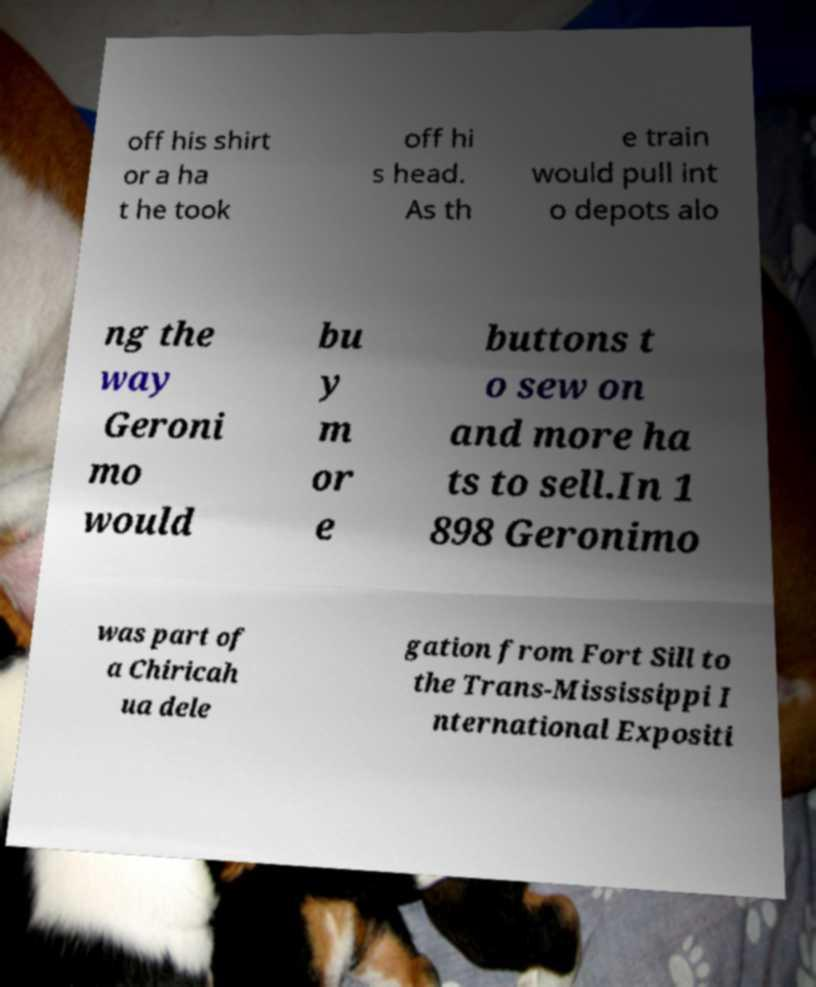Please identify and transcribe the text found in this image. off his shirt or a ha t he took off hi s head. As th e train would pull int o depots alo ng the way Geroni mo would bu y m or e buttons t o sew on and more ha ts to sell.In 1 898 Geronimo was part of a Chiricah ua dele gation from Fort Sill to the Trans-Mississippi I nternational Expositi 